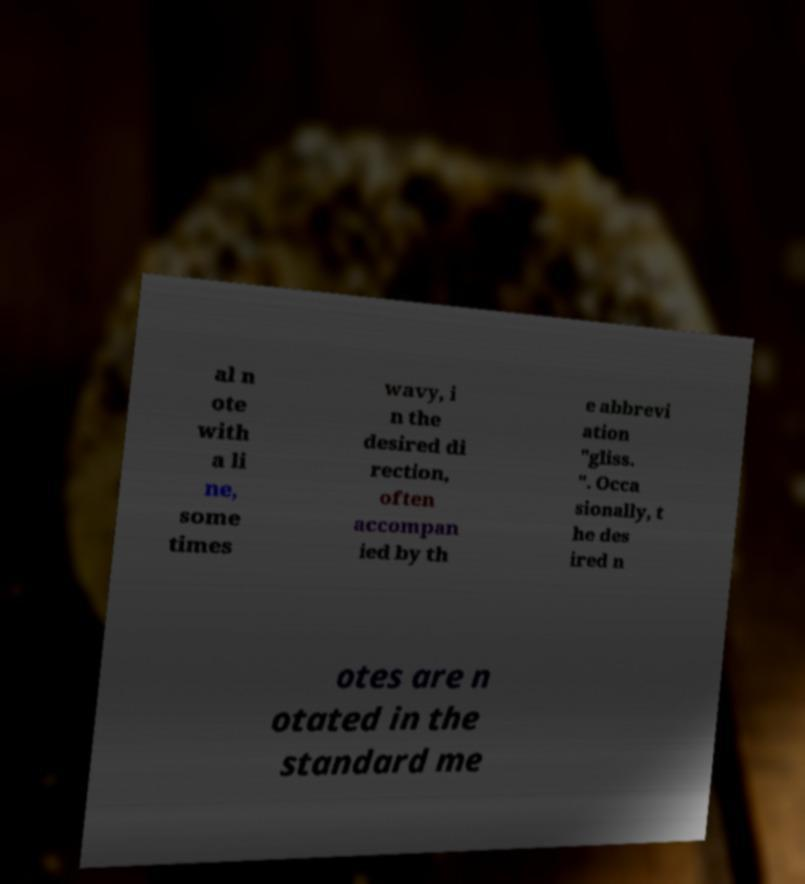Please read and relay the text visible in this image. What does it say? al n ote with a li ne, some times wavy, i n the desired di rection, often accompan ied by th e abbrevi ation "gliss. ". Occa sionally, t he des ired n otes are n otated in the standard me 